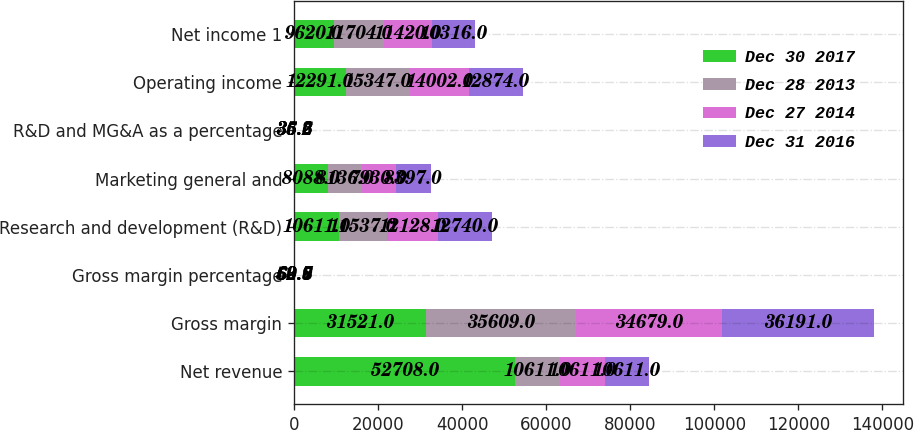<chart> <loc_0><loc_0><loc_500><loc_500><stacked_bar_chart><ecel><fcel>Net revenue<fcel>Gross margin<fcel>Gross margin percentage<fcel>Research and development (R&D)<fcel>Marketing general and<fcel>R&D and MG&A as a percentage<fcel>Operating income<fcel>Net income 1<nl><fcel>Dec 30 2017<fcel>52708<fcel>31521<fcel>59.8<fcel>10611<fcel>8088<fcel>35.5<fcel>12291<fcel>9620<nl><fcel>Dec 28 2013<fcel>10611<fcel>35609<fcel>63.7<fcel>11537<fcel>8136<fcel>35.2<fcel>15347<fcel>11704<nl><fcel>Dec 27 2014<fcel>10611<fcel>34679<fcel>62.6<fcel>12128<fcel>7930<fcel>36.2<fcel>14002<fcel>11420<nl><fcel>Dec 31 2016<fcel>10611<fcel>36191<fcel>60.9<fcel>12740<fcel>8397<fcel>35.6<fcel>12874<fcel>10316<nl></chart> 